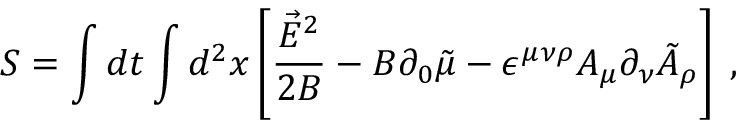<formula> <loc_0><loc_0><loc_500><loc_500>S = \int d t \int d ^ { 2 } x \left [ \frac { \vec { E } ^ { 2 } } { 2 B } - B \partial _ { 0 } \tilde { \mu } - \epsilon ^ { \mu \nu \rho } A _ { \mu } \partial _ { \nu } \tilde { A } _ { \rho } \right ] \, ,</formula> 